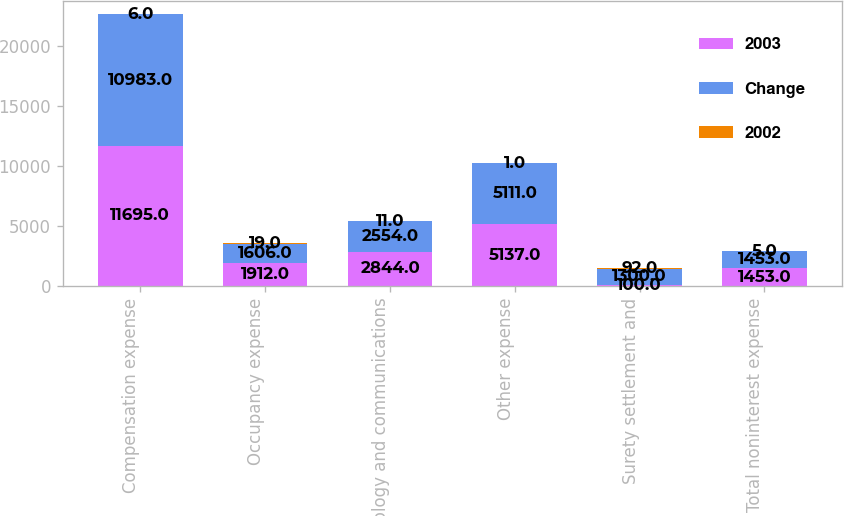Convert chart to OTSL. <chart><loc_0><loc_0><loc_500><loc_500><stacked_bar_chart><ecel><fcel>Compensation expense<fcel>Occupancy expense<fcel>Technology and communications<fcel>Other expense<fcel>Surety settlement and<fcel>Total noninterest expense<nl><fcel>2003<fcel>11695<fcel>1912<fcel>2844<fcel>5137<fcel>100<fcel>1453<nl><fcel>Change<fcel>10983<fcel>1606<fcel>2554<fcel>5111<fcel>1300<fcel>1453<nl><fcel>2002<fcel>6<fcel>19<fcel>11<fcel>1<fcel>92<fcel>5<nl></chart> 